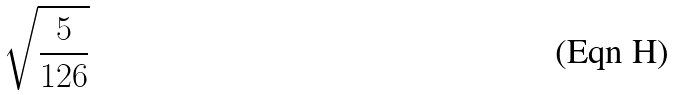Convert formula to latex. <formula><loc_0><loc_0><loc_500><loc_500>\sqrt { \frac { 5 } { 1 2 6 } }</formula> 